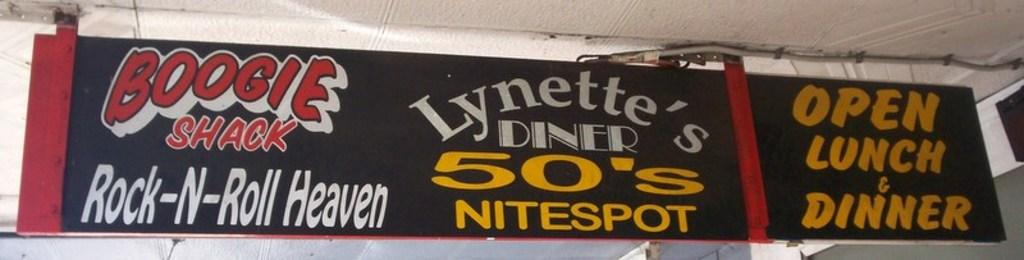What is the main subject in the center of the image? There is an advertisement board in the center of the image. What type of air is being advertised on the board? There is no information about the content of the advertisement. The image only shows an advertisement board. 